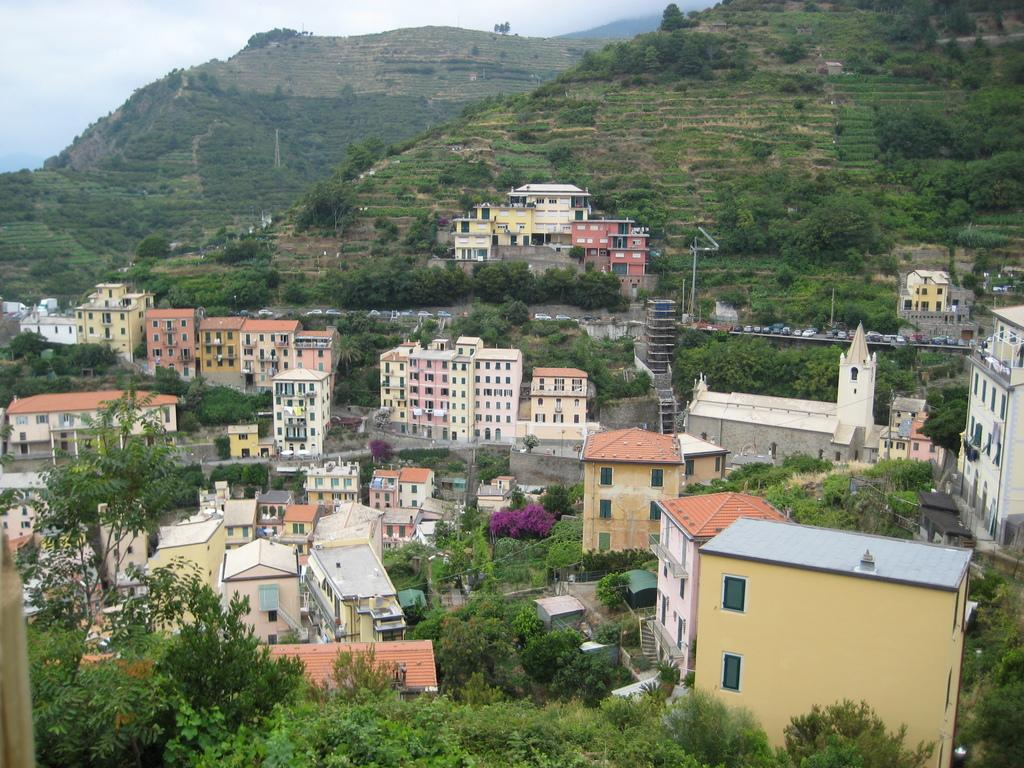What type of natural elements can be seen in the image? There are trees in the image. What type of man-made structures are present in the image? There are buildings in the image. What can be observed on the hills in the image? The hills are covered with plants and trees. What type of shock can be seen affecting the liquid in the image? There is no liquid or shock present in the image. 